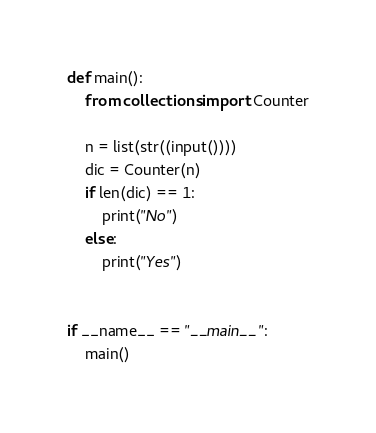Convert code to text. <code><loc_0><loc_0><loc_500><loc_500><_Python_>def main():
    from collections import Counter

    n = list(str((input())))
    dic = Counter(n)
    if len(dic) == 1:
        print("No")
    else:
        print("Yes")


if __name__ == "__main__":
    main()</code> 